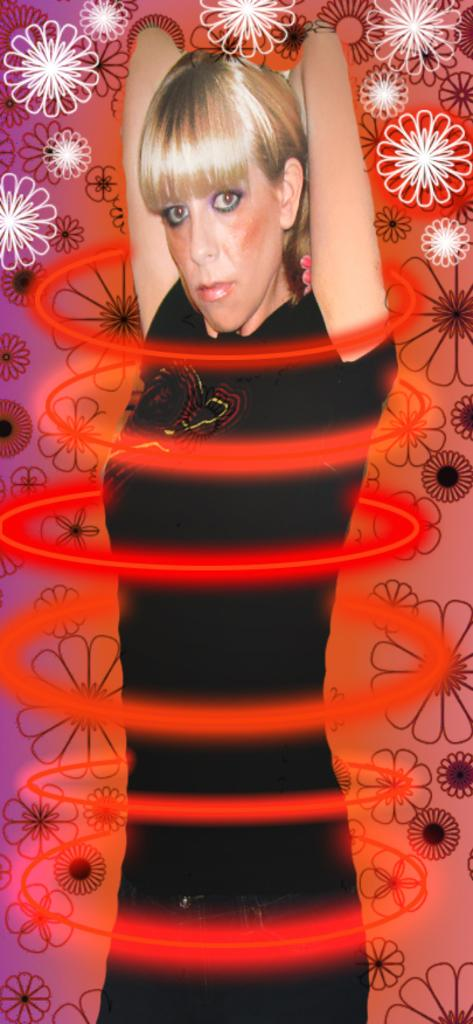What is the main subject of the image? There is a woman standing in the image. What can be seen in the background of the image? There are flower figures in the background of the image. Is the woman playing basketball in the image? There is no basketball or any indication of a basketball game in the image. 